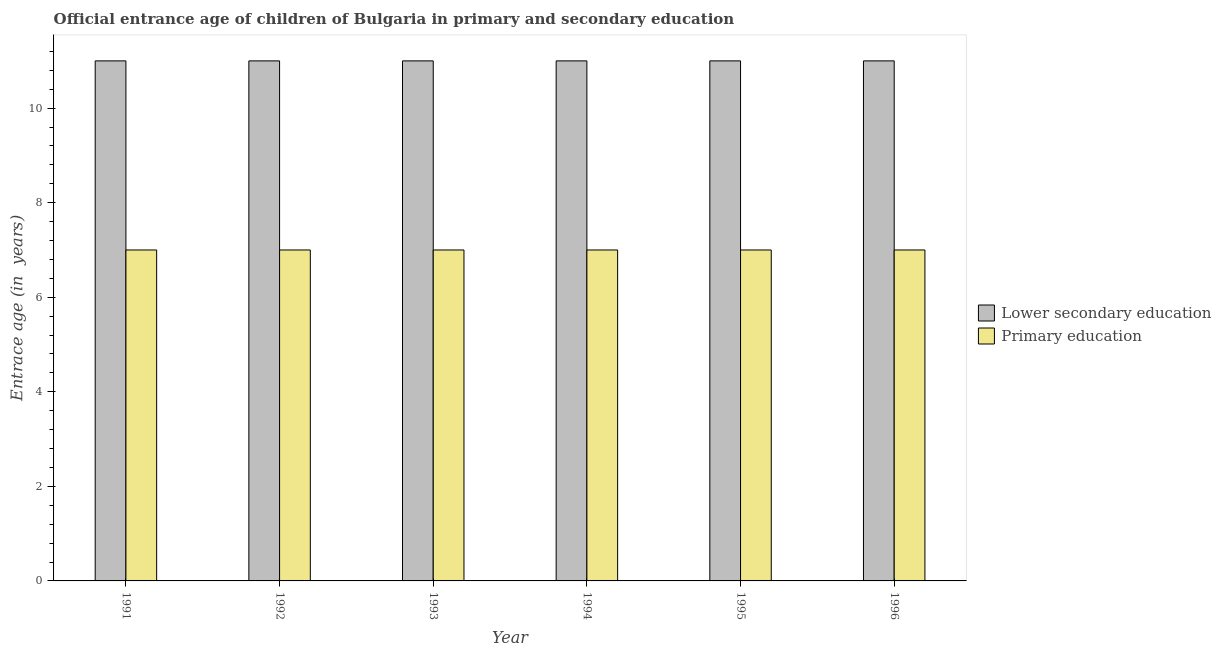How many different coloured bars are there?
Offer a very short reply. 2. How many groups of bars are there?
Keep it short and to the point. 6. Are the number of bars per tick equal to the number of legend labels?
Provide a short and direct response. Yes. How many bars are there on the 6th tick from the left?
Your answer should be very brief. 2. In how many cases, is the number of bars for a given year not equal to the number of legend labels?
Give a very brief answer. 0. What is the entrance age of children in lower secondary education in 1992?
Make the answer very short. 11. Across all years, what is the maximum entrance age of children in lower secondary education?
Provide a short and direct response. 11. Across all years, what is the minimum entrance age of children in lower secondary education?
Give a very brief answer. 11. In which year was the entrance age of chiildren in primary education maximum?
Your response must be concise. 1991. In which year was the entrance age of children in lower secondary education minimum?
Make the answer very short. 1991. What is the total entrance age of chiildren in primary education in the graph?
Make the answer very short. 42. What is the difference between the entrance age of children in lower secondary education in 1994 and that in 1995?
Your answer should be very brief. 0. What is the average entrance age of children in lower secondary education per year?
Provide a succinct answer. 11. What is the ratio of the entrance age of chiildren in primary education in 1994 to that in 1996?
Offer a very short reply. 1. Is the difference between the entrance age of chiildren in primary education in 1995 and 1996 greater than the difference between the entrance age of children in lower secondary education in 1995 and 1996?
Give a very brief answer. No. What does the 1st bar from the left in 1995 represents?
Ensure brevity in your answer.  Lower secondary education. What does the 2nd bar from the right in 1996 represents?
Make the answer very short. Lower secondary education. How many bars are there?
Provide a succinct answer. 12. How many years are there in the graph?
Offer a terse response. 6. Does the graph contain grids?
Offer a terse response. No. How many legend labels are there?
Provide a short and direct response. 2. What is the title of the graph?
Your answer should be very brief. Official entrance age of children of Bulgaria in primary and secondary education. What is the label or title of the Y-axis?
Make the answer very short. Entrace age (in  years). What is the Entrace age (in  years) of Primary education in 1991?
Provide a short and direct response. 7. What is the Entrace age (in  years) of Lower secondary education in 1992?
Make the answer very short. 11. What is the Entrace age (in  years) in Primary education in 1993?
Keep it short and to the point. 7. What is the Entrace age (in  years) of Primary education in 1994?
Provide a short and direct response. 7. What is the Entrace age (in  years) of Primary education in 1995?
Offer a terse response. 7. What is the Entrace age (in  years) in Primary education in 1996?
Your answer should be compact. 7. Across all years, what is the maximum Entrace age (in  years) of Lower secondary education?
Your answer should be very brief. 11. Across all years, what is the maximum Entrace age (in  years) in Primary education?
Offer a very short reply. 7. What is the total Entrace age (in  years) of Lower secondary education in the graph?
Your response must be concise. 66. What is the total Entrace age (in  years) in Primary education in the graph?
Offer a very short reply. 42. What is the difference between the Entrace age (in  years) of Lower secondary education in 1991 and that in 1992?
Your answer should be very brief. 0. What is the difference between the Entrace age (in  years) in Primary education in 1991 and that in 1992?
Keep it short and to the point. 0. What is the difference between the Entrace age (in  years) in Lower secondary education in 1991 and that in 1993?
Give a very brief answer. 0. What is the difference between the Entrace age (in  years) of Primary education in 1991 and that in 1993?
Provide a succinct answer. 0. What is the difference between the Entrace age (in  years) in Lower secondary education in 1991 and that in 1994?
Offer a very short reply. 0. What is the difference between the Entrace age (in  years) of Primary education in 1991 and that in 1994?
Provide a succinct answer. 0. What is the difference between the Entrace age (in  years) in Primary education in 1992 and that in 1993?
Your response must be concise. 0. What is the difference between the Entrace age (in  years) of Primary education in 1992 and that in 1995?
Keep it short and to the point. 0. What is the difference between the Entrace age (in  years) of Primary education in 1992 and that in 1996?
Make the answer very short. 0. What is the difference between the Entrace age (in  years) in Primary education in 1993 and that in 1994?
Offer a very short reply. 0. What is the difference between the Entrace age (in  years) in Primary education in 1993 and that in 1995?
Your answer should be very brief. 0. What is the difference between the Entrace age (in  years) of Primary education in 1993 and that in 1996?
Keep it short and to the point. 0. What is the difference between the Entrace age (in  years) in Primary education in 1994 and that in 1995?
Offer a very short reply. 0. What is the difference between the Entrace age (in  years) in Lower secondary education in 1994 and that in 1996?
Give a very brief answer. 0. What is the difference between the Entrace age (in  years) in Lower secondary education in 1995 and that in 1996?
Your answer should be very brief. 0. What is the difference between the Entrace age (in  years) in Lower secondary education in 1991 and the Entrace age (in  years) in Primary education in 1992?
Keep it short and to the point. 4. What is the difference between the Entrace age (in  years) of Lower secondary education in 1991 and the Entrace age (in  years) of Primary education in 1994?
Ensure brevity in your answer.  4. What is the difference between the Entrace age (in  years) in Lower secondary education in 1993 and the Entrace age (in  years) in Primary education in 1994?
Provide a succinct answer. 4. What is the difference between the Entrace age (in  years) in Lower secondary education in 1995 and the Entrace age (in  years) in Primary education in 1996?
Provide a succinct answer. 4. What is the average Entrace age (in  years) in Lower secondary education per year?
Your response must be concise. 11. In the year 1991, what is the difference between the Entrace age (in  years) of Lower secondary education and Entrace age (in  years) of Primary education?
Give a very brief answer. 4. In the year 1992, what is the difference between the Entrace age (in  years) in Lower secondary education and Entrace age (in  years) in Primary education?
Keep it short and to the point. 4. In the year 1995, what is the difference between the Entrace age (in  years) in Lower secondary education and Entrace age (in  years) in Primary education?
Ensure brevity in your answer.  4. In the year 1996, what is the difference between the Entrace age (in  years) of Lower secondary education and Entrace age (in  years) of Primary education?
Keep it short and to the point. 4. What is the ratio of the Entrace age (in  years) in Lower secondary education in 1991 to that in 1992?
Your answer should be very brief. 1. What is the ratio of the Entrace age (in  years) in Primary education in 1991 to that in 1993?
Offer a terse response. 1. What is the ratio of the Entrace age (in  years) of Primary education in 1991 to that in 1994?
Keep it short and to the point. 1. What is the ratio of the Entrace age (in  years) of Primary education in 1991 to that in 1995?
Offer a terse response. 1. What is the ratio of the Entrace age (in  years) of Lower secondary education in 1991 to that in 1996?
Provide a short and direct response. 1. What is the ratio of the Entrace age (in  years) in Primary education in 1991 to that in 1996?
Your response must be concise. 1. What is the ratio of the Entrace age (in  years) of Primary education in 1992 to that in 1994?
Your response must be concise. 1. What is the ratio of the Entrace age (in  years) of Lower secondary education in 1992 to that in 1995?
Give a very brief answer. 1. What is the ratio of the Entrace age (in  years) of Lower secondary education in 1992 to that in 1996?
Your answer should be very brief. 1. What is the ratio of the Entrace age (in  years) in Primary education in 1992 to that in 1996?
Offer a terse response. 1. What is the ratio of the Entrace age (in  years) of Lower secondary education in 1993 to that in 1995?
Keep it short and to the point. 1. What is the ratio of the Entrace age (in  years) of Primary education in 1993 to that in 1995?
Your response must be concise. 1. What is the ratio of the Entrace age (in  years) in Primary education in 1993 to that in 1996?
Provide a succinct answer. 1. What is the ratio of the Entrace age (in  years) of Lower secondary education in 1994 to that in 1995?
Your answer should be compact. 1. What is the ratio of the Entrace age (in  years) in Lower secondary education in 1994 to that in 1996?
Give a very brief answer. 1. What is the ratio of the Entrace age (in  years) in Primary education in 1994 to that in 1996?
Offer a terse response. 1. What is the ratio of the Entrace age (in  years) of Lower secondary education in 1995 to that in 1996?
Offer a terse response. 1. What is the difference between the highest and the second highest Entrace age (in  years) in Lower secondary education?
Keep it short and to the point. 0. What is the difference between the highest and the lowest Entrace age (in  years) of Lower secondary education?
Give a very brief answer. 0. What is the difference between the highest and the lowest Entrace age (in  years) of Primary education?
Your response must be concise. 0. 